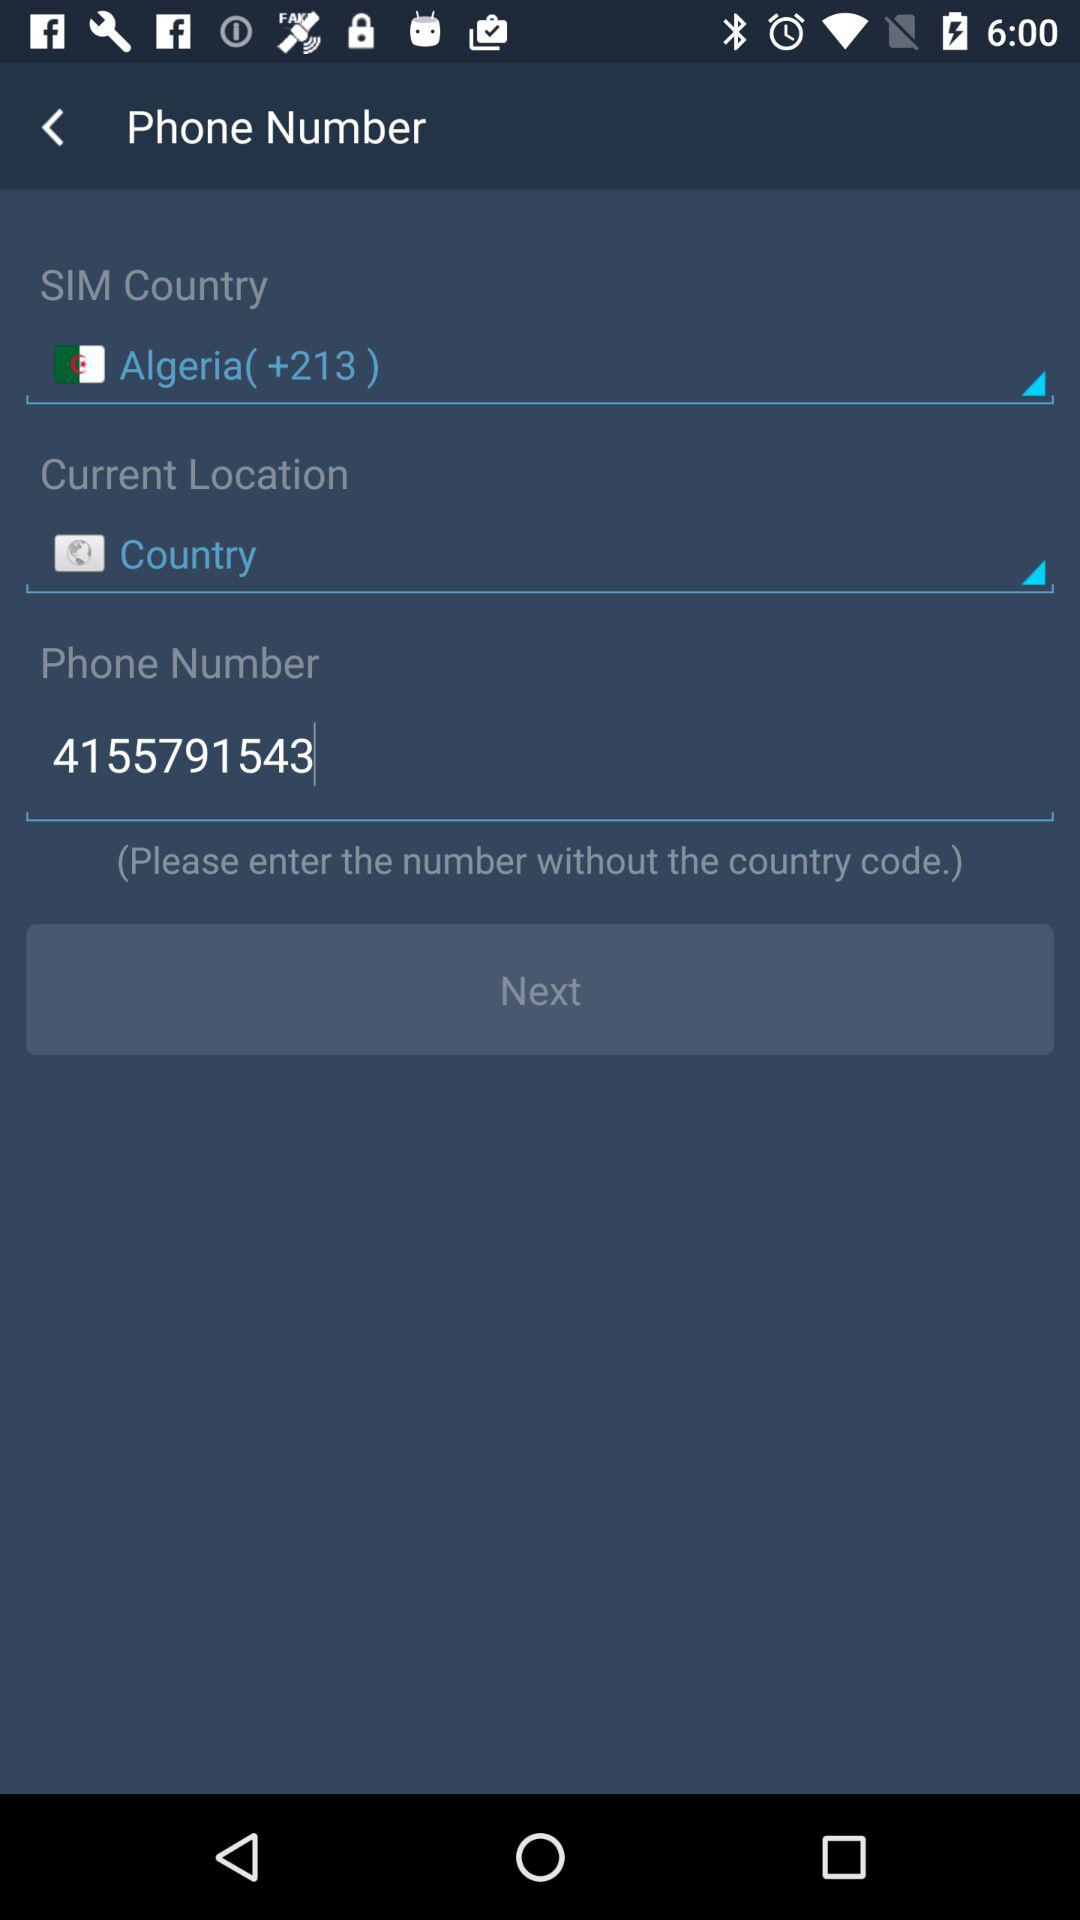Which country is given? The given country is Algeria. 